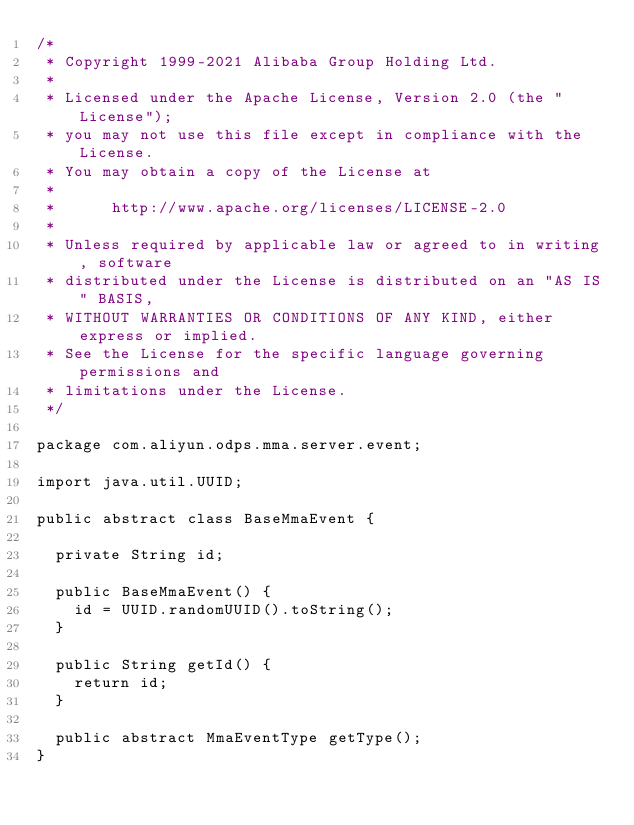<code> <loc_0><loc_0><loc_500><loc_500><_Java_>/*
 * Copyright 1999-2021 Alibaba Group Holding Ltd.
 * 
 * Licensed under the Apache License, Version 2.0 (the "License");
 * you may not use this file except in compliance with the License.
 * You may obtain a copy of the License at
 * 
 *      http://www.apache.org/licenses/LICENSE-2.0
 * 
 * Unless required by applicable law or agreed to in writing, software
 * distributed under the License is distributed on an "AS IS" BASIS,
 * WITHOUT WARRANTIES OR CONDITIONS OF ANY KIND, either express or implied.
 * See the License for the specific language governing permissions and
 * limitations under the License.
 */

package com.aliyun.odps.mma.server.event;

import java.util.UUID;

public abstract class BaseMmaEvent {

  private String id;

  public BaseMmaEvent() {
    id = UUID.randomUUID().toString();
  }

  public String getId() {
    return id;
  }

  public abstract MmaEventType getType();
}
</code> 